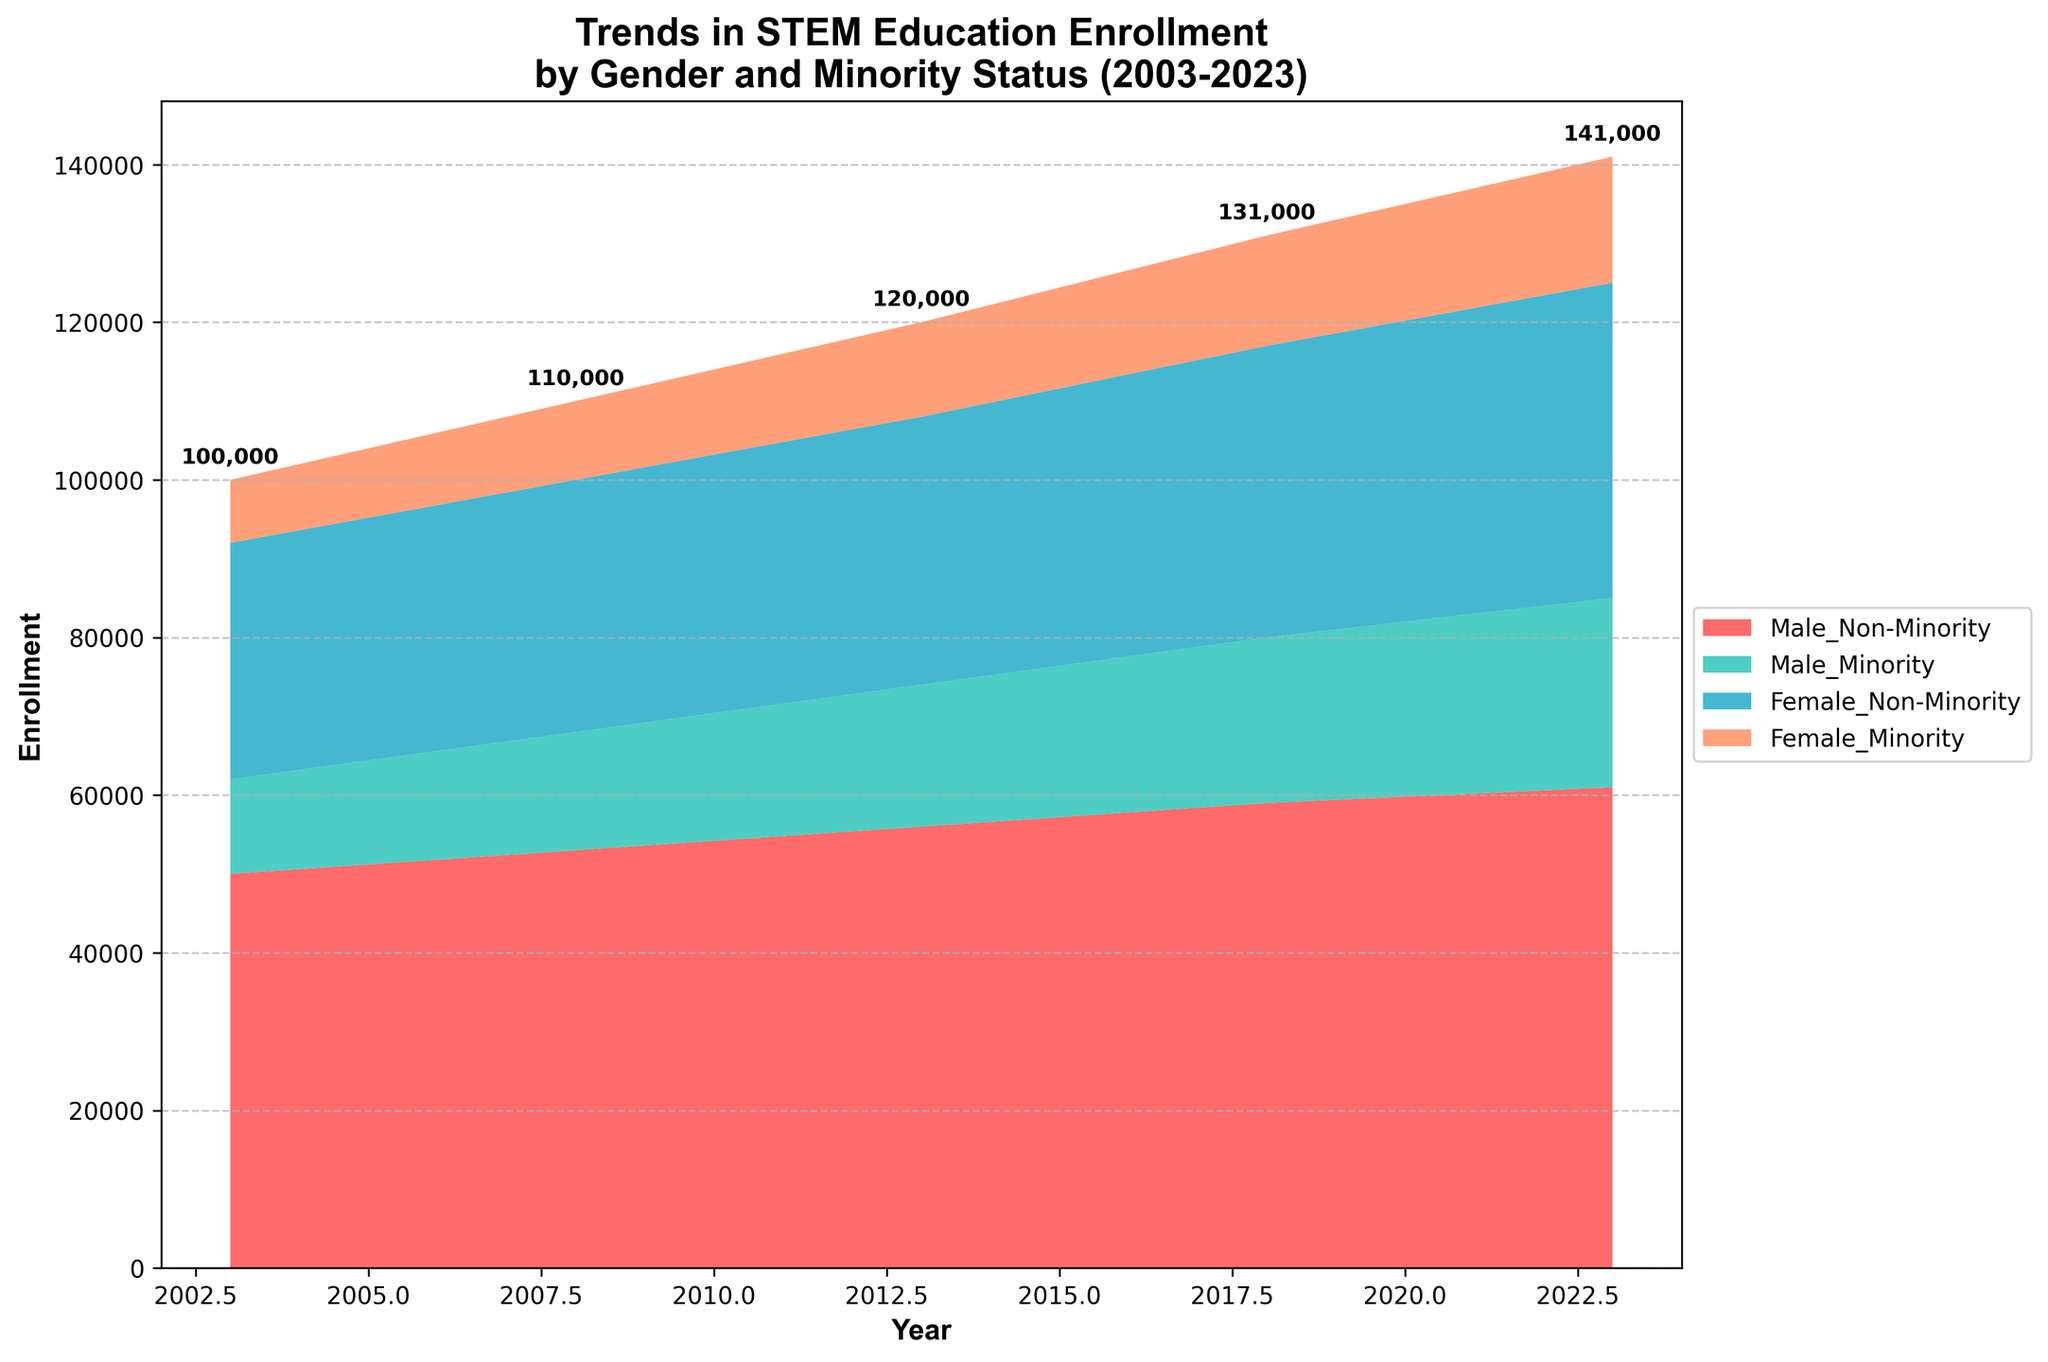What is the title of the figure? The title is usually provided at the top of the figure. By looking at the top part of the plot, you can see the title clearly stated.
Answer: Trends in STEM Education Enrollment by Gender and Minority Status (2003-2023) What is displayed on the x-axis? The x-axis generally represents the categories or range across which the data is plotted, in this case, it shows a range of years.
Answer: Year What are the units on the y-axis? The y-axis displays what is being measured or counted on a numerical scale, which in this case is the number of enrollments.
Answer: Enrollment Which category had the highest enrollment in the year 2023? By observing the section of the stream graph corresponding to the year 2023, you can identify which category has the greatest vertical extent in that segment.
Answer: Male_Non-Minority How has the total enrollment changed from 2003 to 2023? To determine this, look at the sum of all categories' heights at the start and end of the series. The annotations at each year can help indicate the total enrollment values.
Answer: Increased by 50,000 Which gender and minority status group showed the most growth in enrollment from 2003 to 2023? By comparing the heights of each segment between 2003 and 2023, you can determine which one has the largest increase.
Answer: Male_Minority Between which years did Female_Minority enrollments see the most significant rise? To find this, observe the segment corresponding to Female_Minority and note any major increases between consecutive years.
Answer: 2008-2013 How does the growth rate of Female_Non-Minority enrollment compare to Male_Non-Minority between 2003 and 2023? Observe the respective segments for each category and compare the difference in heights from the starting to ending year. Calculate and compare the overall increase in enrollment for both categories.
Answer: Female_Non-Minority had a lower growth rate than Male_Non-Minority What is the difference in total enrollment between Male_Non-Minority and Female_Minority in the year 2013? Find the height of each category in the year 2013 and subtract the enrollment value of Female_Minority from Male_Non-Minority.
Answer: 44,000 Which group had the least variability in enrollment over the past 20 years? Variability can be inferred by observing the changes in the height of the segment across different years. The group with the least fluctuations over the years has the least variability.
Answer: Female_Non-Minority 